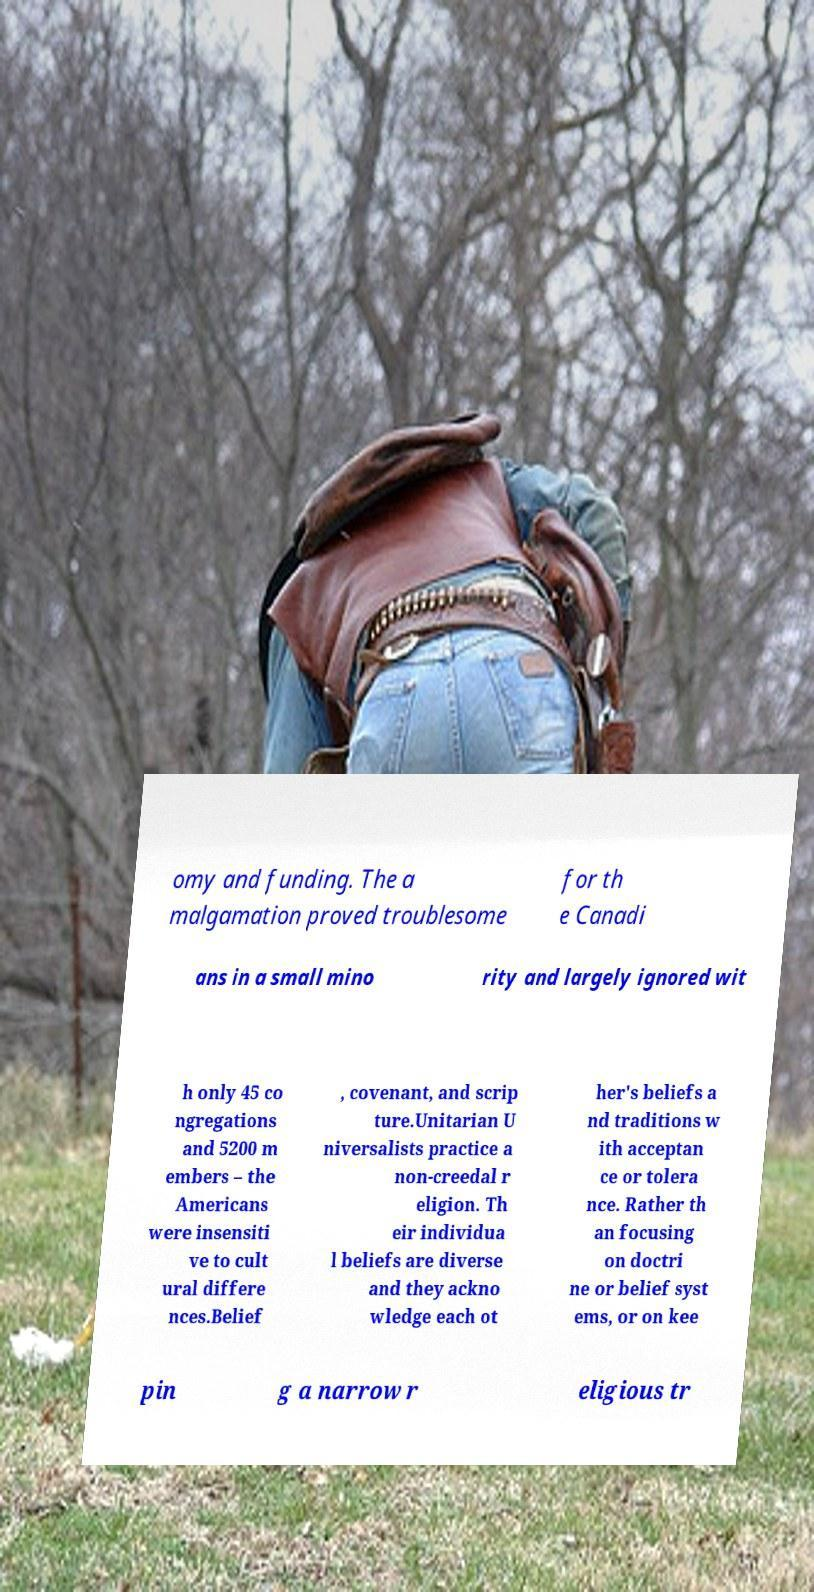I need the written content from this picture converted into text. Can you do that? omy and funding. The a malgamation proved troublesome for th e Canadi ans in a small mino rity and largely ignored wit h only 45 co ngregations and 5200 m embers – the Americans were insensiti ve to cult ural differe nces.Belief , covenant, and scrip ture.Unitarian U niversalists practice a non-creedal r eligion. Th eir individua l beliefs are diverse and they ackno wledge each ot her's beliefs a nd traditions w ith acceptan ce or tolera nce. Rather th an focusing on doctri ne or belief syst ems, or on kee pin g a narrow r eligious tr 